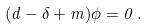<formula> <loc_0><loc_0><loc_500><loc_500>( d - \delta + m ) { \phi } = 0 \, .</formula> 